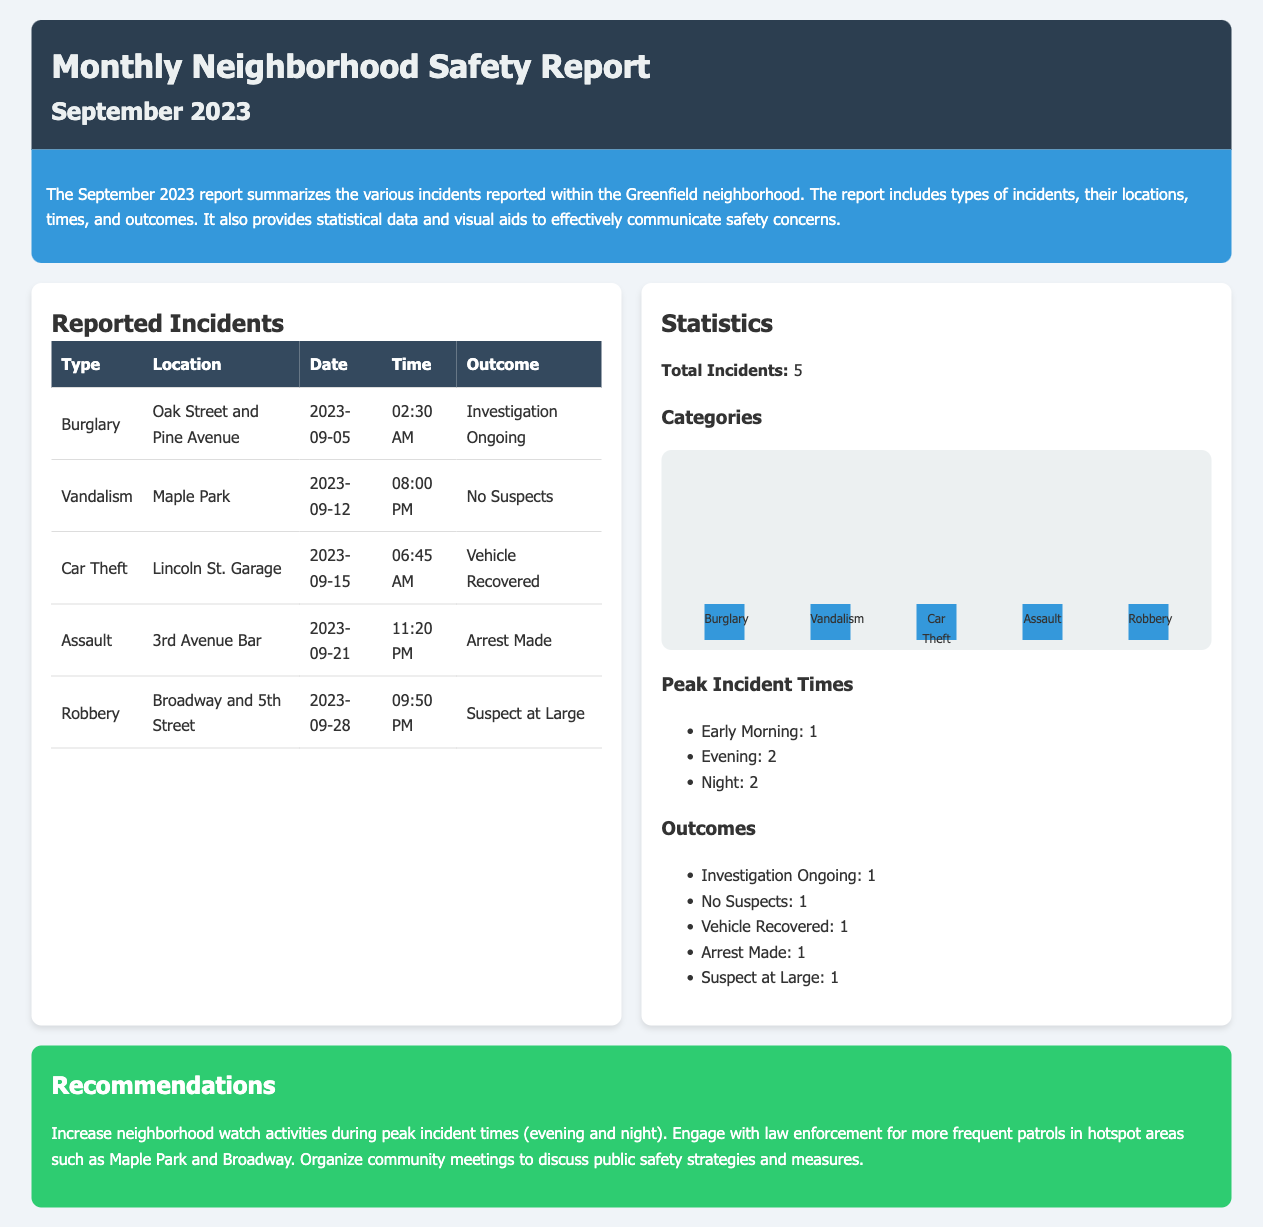What was the total number of reported incidents? The total number of reported incidents is stated in the statistics section as 5.
Answer: 5 What type of incident occurred on September 21? The type of incident that occurred on September 21 is noted in the reported incidents table.
Answer: Assault What outcome was reported for the burglary incident? The outcome for the burglary incident is listed in the reported incidents table.
Answer: Investigation Ongoing Which location had a car theft incident? The location where the car theft incident occurred is found in the reported incidents table.
Answer: Lincoln St. Garage During which time period were the most incidents reported? The statistics detail the number of incidents during different times and indicate peak periods.
Answer: Evening and Night What was the outcome of the car theft incident? The outcome of the car theft incident is included in the reported incidents table.
Answer: Vehicle Recovered How many incidents were reported with "Suspect at Large" outcome? The count of incidents with the "Suspect at Large" outcome is mentioned in the outcomes list.
Answer: 1 What recommendation is given for neighborhood watch activities? The recommendations section provides guidance on neighborhood watch activities during specific times.
Answer: Peak incident times (evening and night) How many categories of incidents are represented in the chart? The chart outlines the distribution of different incident types indicated in the statistics section.
Answer: 5 